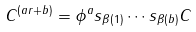<formula> <loc_0><loc_0><loc_500><loc_500>C ^ { ( a r + b ) } = \phi ^ { a } s _ { \beta ( 1 ) } \cdots s _ { \beta ( b ) } C</formula> 